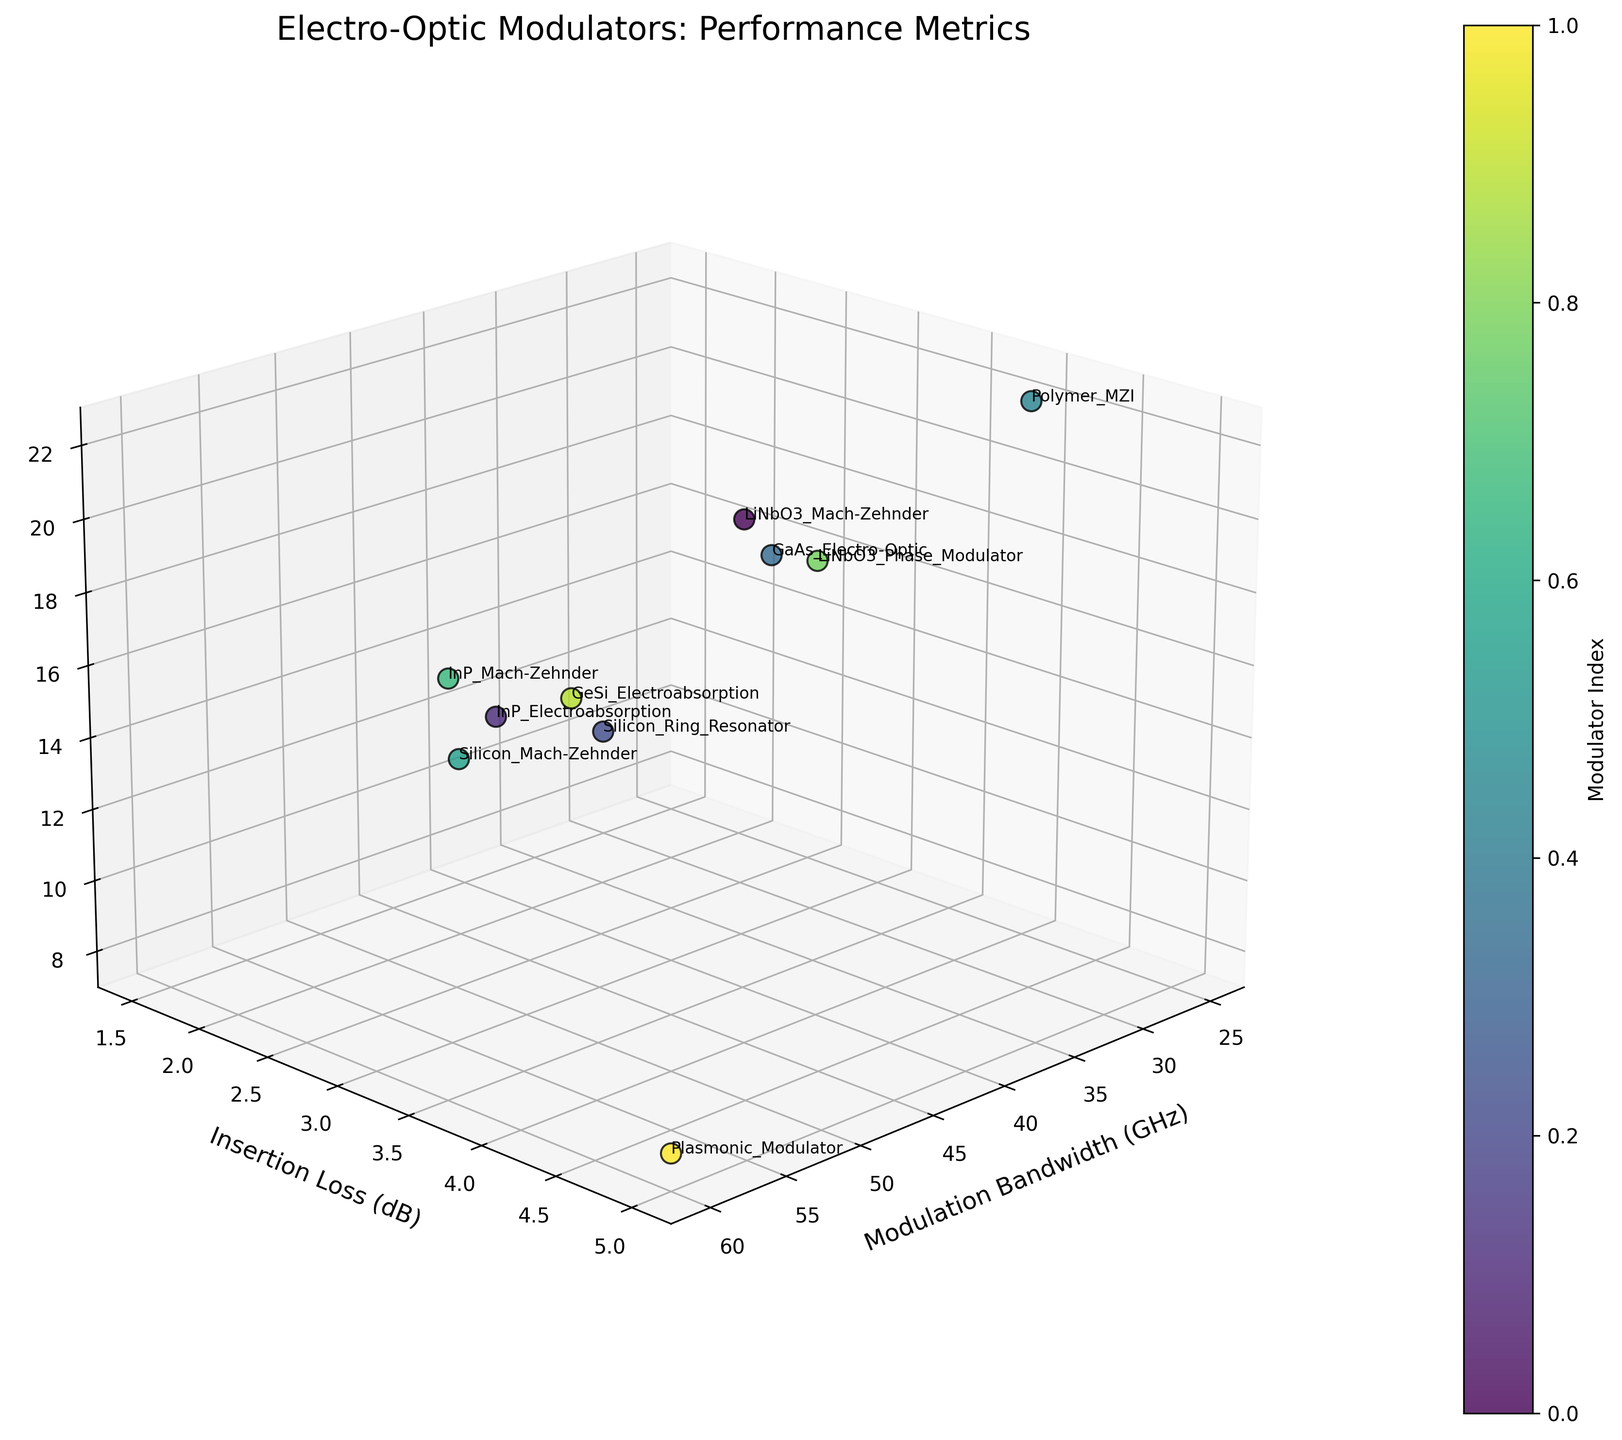How many modulators are represented in the figure? Count the number of data points or labels presented in the scatter plot.
Answer: 10 Which modulator has the highest modulation bandwidth? Look for the data point with the largest value on the Modulation Bandwidth axis.
Answer: Plasmonic Modulator Which modulator has the lowest extinction ratio? Identify the data point with the smallest value on the Extinction Ratio axis.
Answer: Plasmonic Modulator What is the modulation bandwidth range depicted in the plot? Determine the minimum and maximum values on the Modulation Bandwidth axis, then find the difference between them.
Answer: 25-60 GHz Which modulator appears to be closest to the origin based on their coordinates? Find the data point with the smallest values for Modulation Bandwidth, Insertion Loss, and Extinction Ratio.
Answer: Silicon Ring Resonator Are there any modulators with an insertion loss greater than 4 dB? If so, which ones? Check the data points with values on the Insertion Loss axis greater than 4 dB.
Answer: Polymer MZI, Plasmonic Modulator Which modulator has the second highest extinction ratio? Locate the data point with the second largest value on the Extinction Ratio axis.
Answer: Polymer MZI What is the average modulation bandwidth of all the modulators? Add all the modulation bandwidth values and then divide by the number of modulators. Steps: (40 + 50 + 30 + 35 + 25 + 45 + 55 + 38 + 42 + 60) / 10
Answer: 42 GHz Which two modulators have similar insertion loss values but different modulation bandwidths? Identify data points with nearly the same y-values (Insertion Loss) but different x-values (Modulation Bandwidth).
Answer: LiNbO3 Mach-Zehnder and GaAs Electro-Optic Based on the plot, which modulator would you choose to maximize both modulation bandwidth and extinction ratio? Look for the modulator that has high values in both Modulation Bandwidth and Extinction Ratio axes.
Answer: InP Mach-Zehnder 